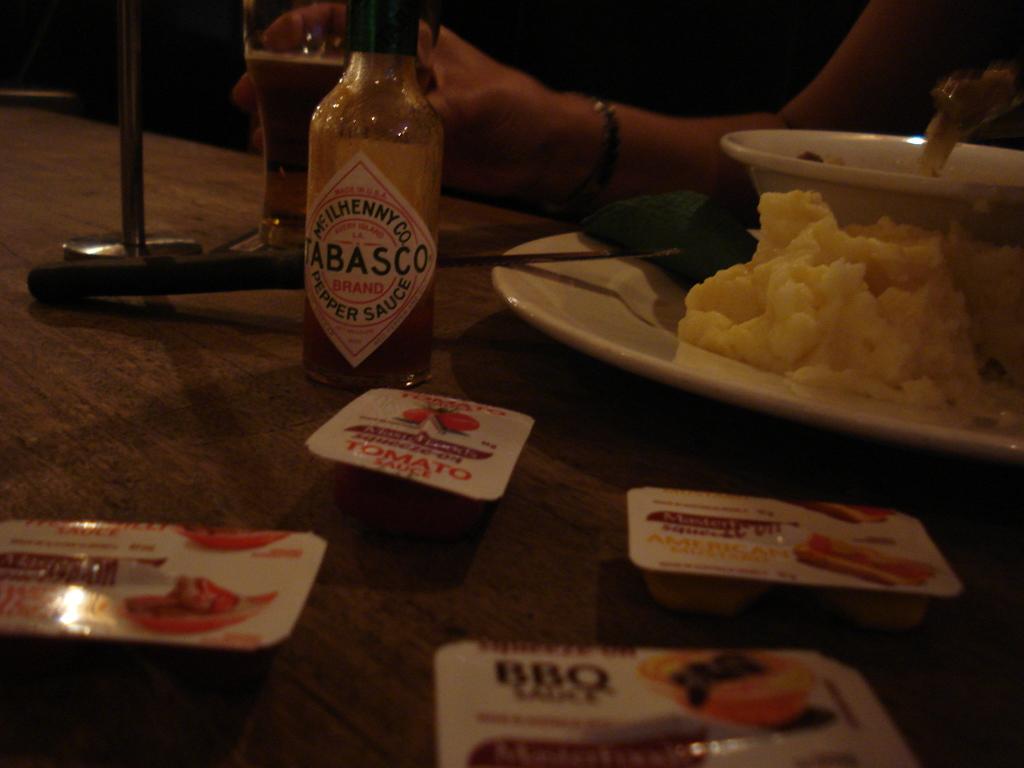What kind of sauce is at the table?
Make the answer very short. Tabasco. What kind of sauce is in the bottom right?
Ensure brevity in your answer.  Bbq. 